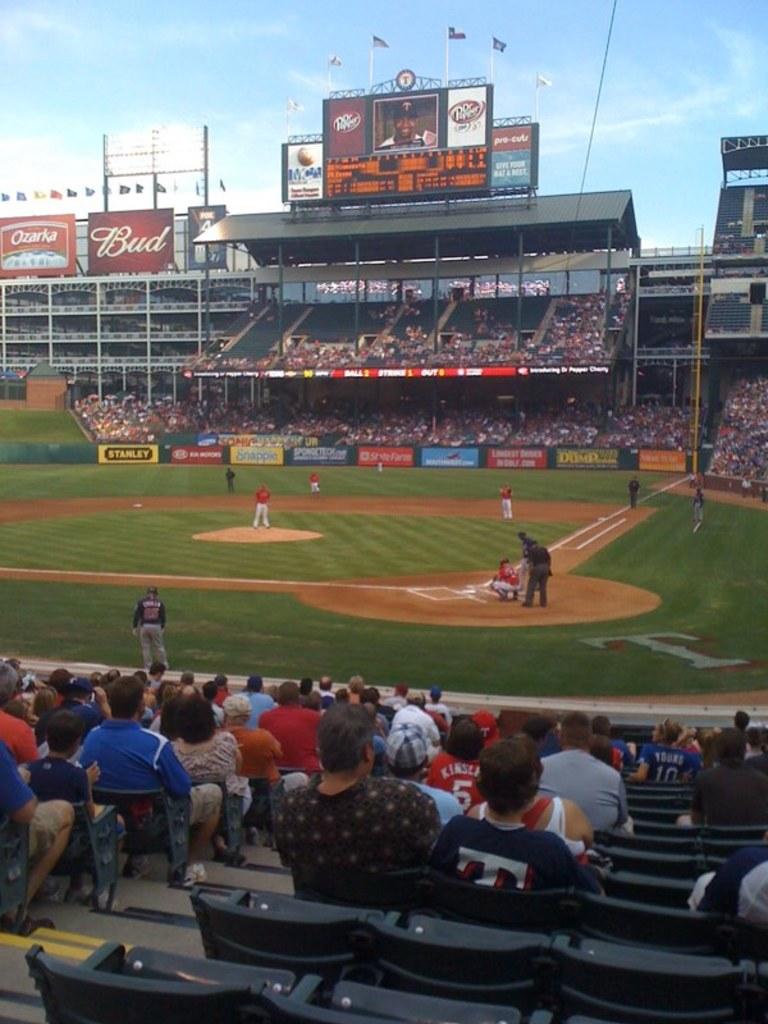What is the beer company advertising in the back?
Offer a terse response. Bud. What soda is shown on the top of the score board?
Your answer should be very brief. Dr pepper. 